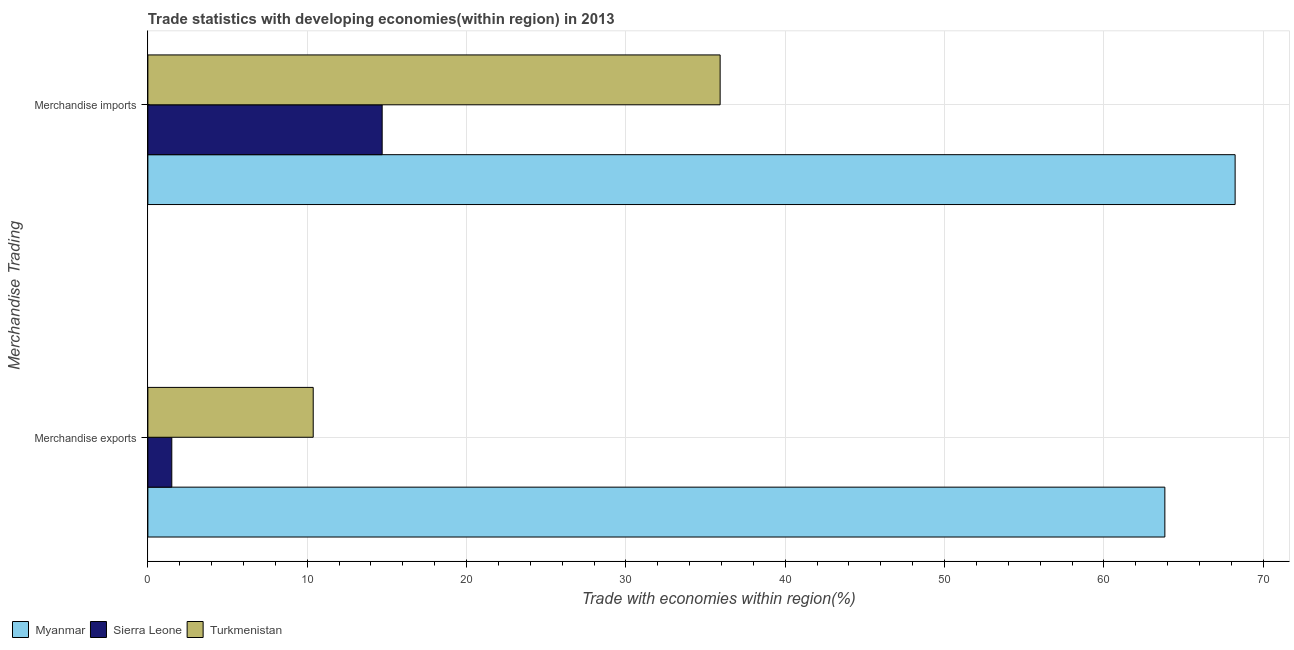How many groups of bars are there?
Your answer should be very brief. 2. Are the number of bars per tick equal to the number of legend labels?
Provide a succinct answer. Yes. Are the number of bars on each tick of the Y-axis equal?
Provide a succinct answer. Yes. How many bars are there on the 2nd tick from the top?
Provide a short and direct response. 3. How many bars are there on the 1st tick from the bottom?
Your response must be concise. 3. What is the merchandise exports in Turkmenistan?
Offer a very short reply. 10.38. Across all countries, what is the maximum merchandise imports?
Provide a succinct answer. 68.23. Across all countries, what is the minimum merchandise imports?
Provide a short and direct response. 14.7. In which country was the merchandise exports maximum?
Keep it short and to the point. Myanmar. In which country was the merchandise exports minimum?
Provide a short and direct response. Sierra Leone. What is the total merchandise imports in the graph?
Ensure brevity in your answer.  118.85. What is the difference between the merchandise exports in Sierra Leone and that in Myanmar?
Offer a very short reply. -62.32. What is the difference between the merchandise exports in Turkmenistan and the merchandise imports in Myanmar?
Offer a very short reply. -57.86. What is the average merchandise exports per country?
Ensure brevity in your answer.  25.23. What is the difference between the merchandise exports and merchandise imports in Myanmar?
Offer a very short reply. -4.41. In how many countries, is the merchandise exports greater than 48 %?
Provide a succinct answer. 1. What is the ratio of the merchandise imports in Sierra Leone to that in Myanmar?
Offer a very short reply. 0.22. Is the merchandise exports in Turkmenistan less than that in Sierra Leone?
Provide a short and direct response. No. What does the 2nd bar from the top in Merchandise exports represents?
Your response must be concise. Sierra Leone. What does the 2nd bar from the bottom in Merchandise imports represents?
Offer a terse response. Sierra Leone. Are all the bars in the graph horizontal?
Your answer should be very brief. Yes. How many countries are there in the graph?
Your answer should be compact. 3. What is the difference between two consecutive major ticks on the X-axis?
Offer a terse response. 10. Are the values on the major ticks of X-axis written in scientific E-notation?
Offer a very short reply. No. Does the graph contain grids?
Offer a very short reply. Yes. How many legend labels are there?
Your answer should be very brief. 3. How are the legend labels stacked?
Provide a succinct answer. Horizontal. What is the title of the graph?
Provide a succinct answer. Trade statistics with developing economies(within region) in 2013. What is the label or title of the X-axis?
Ensure brevity in your answer.  Trade with economies within region(%). What is the label or title of the Y-axis?
Offer a very short reply. Merchandise Trading. What is the Trade with economies within region(%) of Myanmar in Merchandise exports?
Your response must be concise. 63.82. What is the Trade with economies within region(%) of Sierra Leone in Merchandise exports?
Provide a short and direct response. 1.5. What is the Trade with economies within region(%) in Turkmenistan in Merchandise exports?
Ensure brevity in your answer.  10.38. What is the Trade with economies within region(%) of Myanmar in Merchandise imports?
Make the answer very short. 68.23. What is the Trade with economies within region(%) of Sierra Leone in Merchandise imports?
Your answer should be compact. 14.7. What is the Trade with economies within region(%) of Turkmenistan in Merchandise imports?
Provide a short and direct response. 35.91. Across all Merchandise Trading, what is the maximum Trade with economies within region(%) of Myanmar?
Offer a terse response. 68.23. Across all Merchandise Trading, what is the maximum Trade with economies within region(%) in Sierra Leone?
Provide a short and direct response. 14.7. Across all Merchandise Trading, what is the maximum Trade with economies within region(%) in Turkmenistan?
Keep it short and to the point. 35.91. Across all Merchandise Trading, what is the minimum Trade with economies within region(%) in Myanmar?
Make the answer very short. 63.82. Across all Merchandise Trading, what is the minimum Trade with economies within region(%) of Sierra Leone?
Make the answer very short. 1.5. Across all Merchandise Trading, what is the minimum Trade with economies within region(%) in Turkmenistan?
Make the answer very short. 10.38. What is the total Trade with economies within region(%) of Myanmar in the graph?
Provide a short and direct response. 132.06. What is the total Trade with economies within region(%) of Sierra Leone in the graph?
Offer a very short reply. 16.21. What is the total Trade with economies within region(%) of Turkmenistan in the graph?
Ensure brevity in your answer.  46.29. What is the difference between the Trade with economies within region(%) of Myanmar in Merchandise exports and that in Merchandise imports?
Your answer should be very brief. -4.41. What is the difference between the Trade with economies within region(%) in Sierra Leone in Merchandise exports and that in Merchandise imports?
Your answer should be very brief. -13.2. What is the difference between the Trade with economies within region(%) in Turkmenistan in Merchandise exports and that in Merchandise imports?
Provide a short and direct response. -25.54. What is the difference between the Trade with economies within region(%) in Myanmar in Merchandise exports and the Trade with economies within region(%) in Sierra Leone in Merchandise imports?
Your answer should be compact. 49.12. What is the difference between the Trade with economies within region(%) in Myanmar in Merchandise exports and the Trade with economies within region(%) in Turkmenistan in Merchandise imports?
Make the answer very short. 27.91. What is the difference between the Trade with economies within region(%) of Sierra Leone in Merchandise exports and the Trade with economies within region(%) of Turkmenistan in Merchandise imports?
Provide a succinct answer. -34.41. What is the average Trade with economies within region(%) in Myanmar per Merchandise Trading?
Your answer should be very brief. 66.03. What is the average Trade with economies within region(%) of Sierra Leone per Merchandise Trading?
Your answer should be compact. 8.1. What is the average Trade with economies within region(%) of Turkmenistan per Merchandise Trading?
Provide a short and direct response. 23.15. What is the difference between the Trade with economies within region(%) of Myanmar and Trade with economies within region(%) of Sierra Leone in Merchandise exports?
Give a very brief answer. 62.32. What is the difference between the Trade with economies within region(%) of Myanmar and Trade with economies within region(%) of Turkmenistan in Merchandise exports?
Make the answer very short. 53.45. What is the difference between the Trade with economies within region(%) in Sierra Leone and Trade with economies within region(%) in Turkmenistan in Merchandise exports?
Make the answer very short. -8.88. What is the difference between the Trade with economies within region(%) in Myanmar and Trade with economies within region(%) in Sierra Leone in Merchandise imports?
Make the answer very short. 53.53. What is the difference between the Trade with economies within region(%) of Myanmar and Trade with economies within region(%) of Turkmenistan in Merchandise imports?
Ensure brevity in your answer.  32.32. What is the difference between the Trade with economies within region(%) of Sierra Leone and Trade with economies within region(%) of Turkmenistan in Merchandise imports?
Your response must be concise. -21.21. What is the ratio of the Trade with economies within region(%) of Myanmar in Merchandise exports to that in Merchandise imports?
Ensure brevity in your answer.  0.94. What is the ratio of the Trade with economies within region(%) of Sierra Leone in Merchandise exports to that in Merchandise imports?
Offer a terse response. 0.1. What is the ratio of the Trade with economies within region(%) in Turkmenistan in Merchandise exports to that in Merchandise imports?
Your answer should be compact. 0.29. What is the difference between the highest and the second highest Trade with economies within region(%) in Myanmar?
Give a very brief answer. 4.41. What is the difference between the highest and the second highest Trade with economies within region(%) of Sierra Leone?
Your response must be concise. 13.2. What is the difference between the highest and the second highest Trade with economies within region(%) in Turkmenistan?
Your response must be concise. 25.54. What is the difference between the highest and the lowest Trade with economies within region(%) in Myanmar?
Your answer should be compact. 4.41. What is the difference between the highest and the lowest Trade with economies within region(%) in Sierra Leone?
Keep it short and to the point. 13.2. What is the difference between the highest and the lowest Trade with economies within region(%) of Turkmenistan?
Your response must be concise. 25.54. 